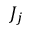Convert formula to latex. <formula><loc_0><loc_0><loc_500><loc_500>J _ { j }</formula> 